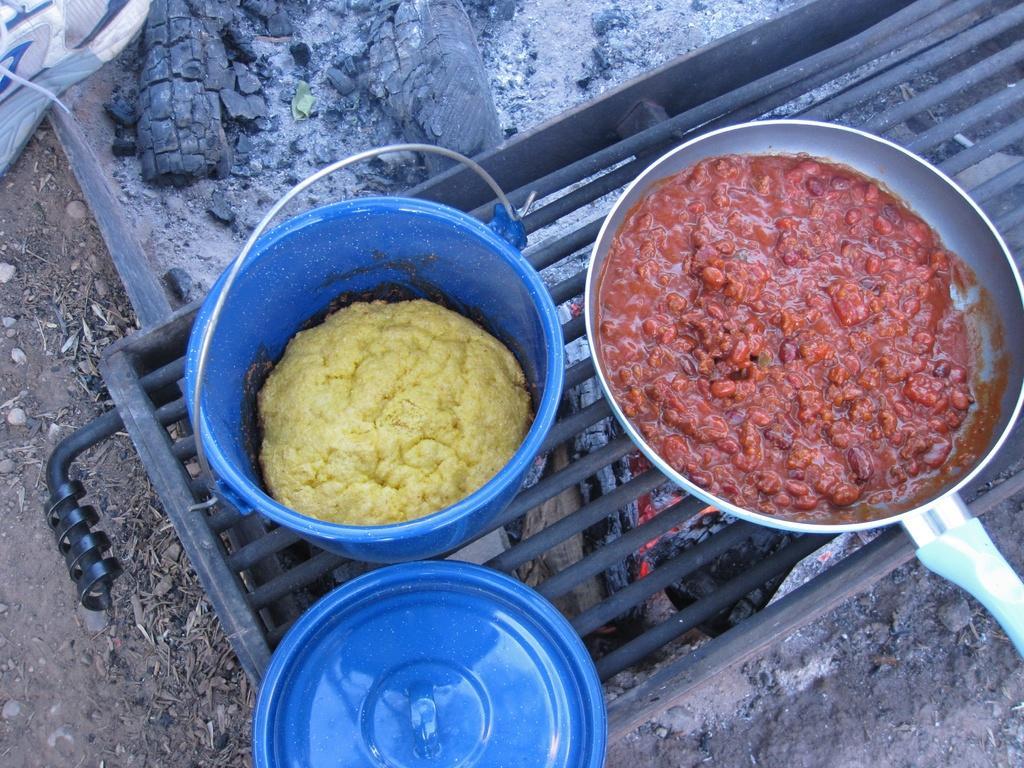Please provide a concise description of this image. In this picture we can see a pan, a bowl and a cap present on grilles, we can see some food in this pan and bowl, at the bottom we can see ash and some stones, we can see a shoe at the left top of the picture. 